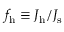<formula> <loc_0><loc_0><loc_500><loc_500>f _ { h } \equiv { J _ { h } } / { J _ { s } }</formula> 